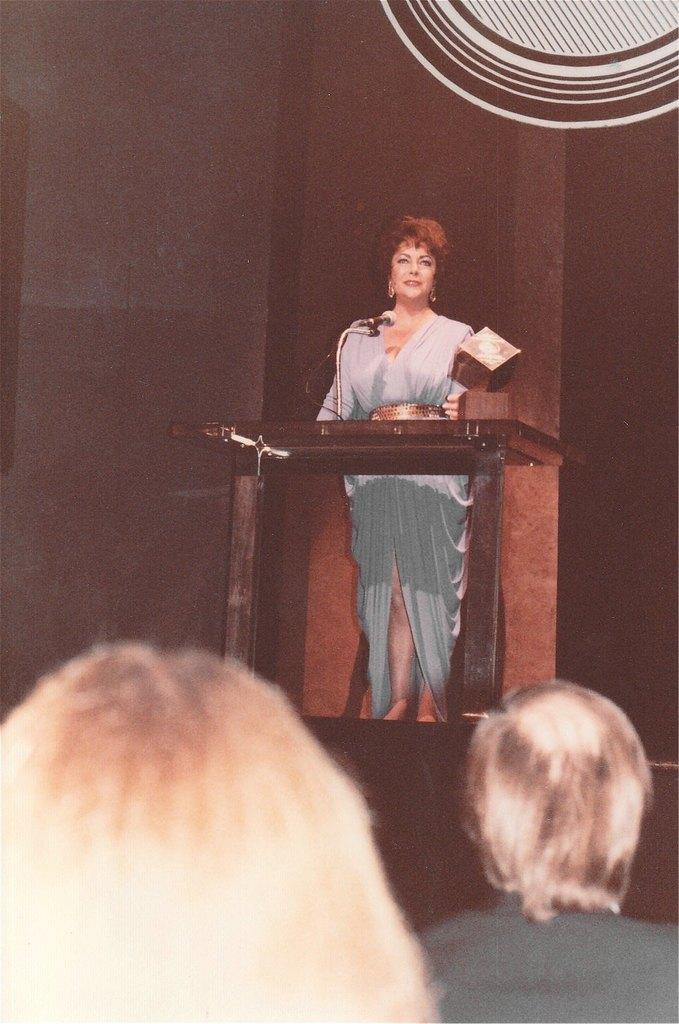Please provide a concise description of this image. In this image we can see a person standing in front of a podium and behind the person we can see a wall. At the bottom we can see two persons. 